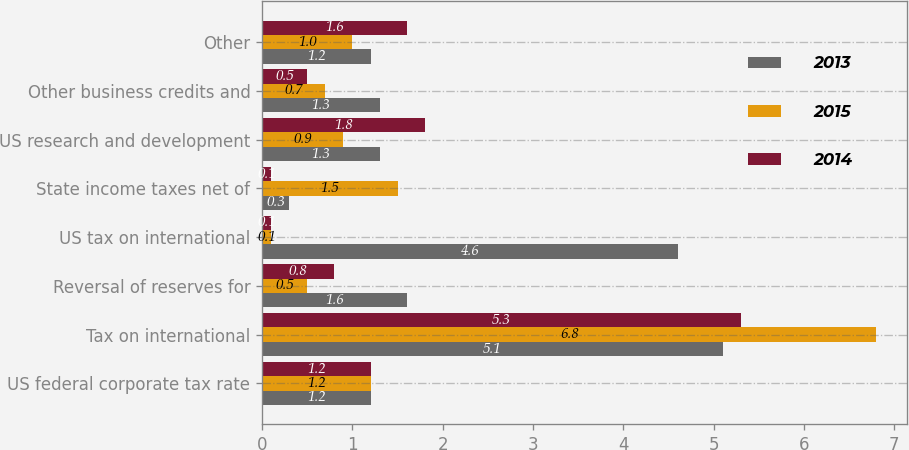<chart> <loc_0><loc_0><loc_500><loc_500><stacked_bar_chart><ecel><fcel>US federal corporate tax rate<fcel>Tax on international<fcel>Reversal of reserves for<fcel>US tax on international<fcel>State income taxes net of<fcel>US research and development<fcel>Other business credits and<fcel>Other<nl><fcel>2013<fcel>1.2<fcel>5.1<fcel>1.6<fcel>4.6<fcel>0.3<fcel>1.3<fcel>1.3<fcel>1.2<nl><fcel>2015<fcel>1.2<fcel>6.8<fcel>0.5<fcel>0.1<fcel>1.5<fcel>0.9<fcel>0.7<fcel>1<nl><fcel>2014<fcel>1.2<fcel>5.3<fcel>0.8<fcel>0.1<fcel>0.1<fcel>1.8<fcel>0.5<fcel>1.6<nl></chart> 